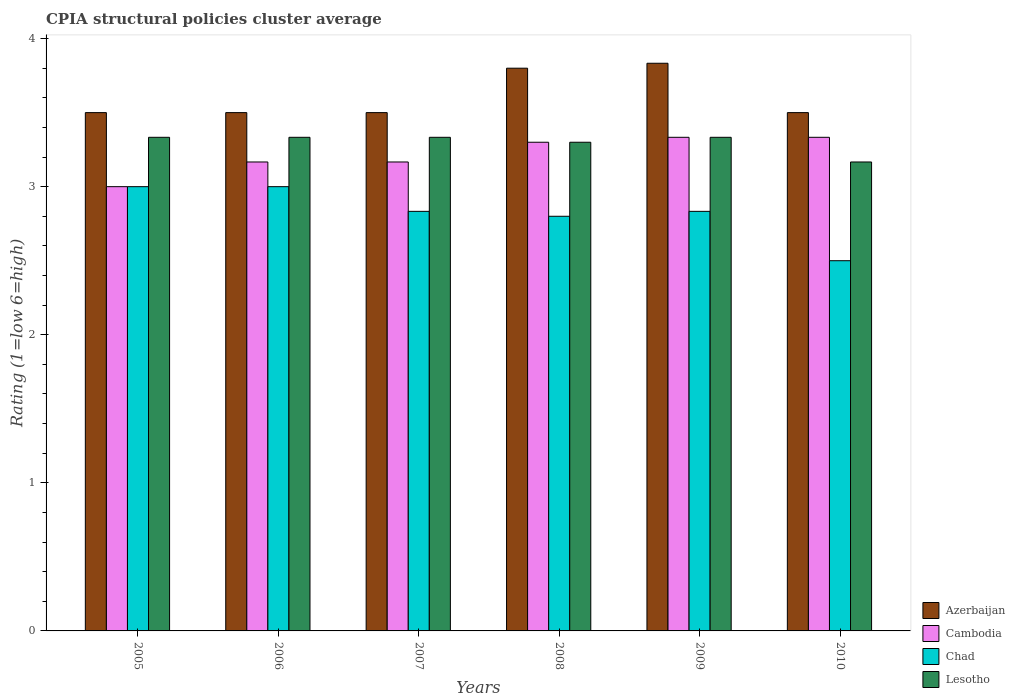Are the number of bars on each tick of the X-axis equal?
Your response must be concise. Yes. How many bars are there on the 5th tick from the right?
Your answer should be very brief. 4. What is the CPIA rating in Azerbaijan in 2010?
Give a very brief answer. 3.5. Across all years, what is the maximum CPIA rating in Lesotho?
Give a very brief answer. 3.33. Across all years, what is the minimum CPIA rating in Azerbaijan?
Your response must be concise. 3.5. In which year was the CPIA rating in Lesotho maximum?
Your response must be concise. 2005. What is the total CPIA rating in Lesotho in the graph?
Make the answer very short. 19.8. What is the difference between the CPIA rating in Chad in 2005 and that in 2010?
Keep it short and to the point. 0.5. What is the difference between the CPIA rating in Azerbaijan in 2007 and the CPIA rating in Chad in 2009?
Keep it short and to the point. 0.67. What is the average CPIA rating in Lesotho per year?
Ensure brevity in your answer.  3.3. In the year 2010, what is the difference between the CPIA rating in Chad and CPIA rating in Lesotho?
Give a very brief answer. -0.67. In how many years, is the CPIA rating in Lesotho greater than 1.2?
Offer a very short reply. 6. What is the ratio of the CPIA rating in Cambodia in 2005 to that in 2007?
Provide a short and direct response. 0.95. Is the CPIA rating in Cambodia in 2006 less than that in 2009?
Your response must be concise. Yes. Is the difference between the CPIA rating in Chad in 2008 and 2010 greater than the difference between the CPIA rating in Lesotho in 2008 and 2010?
Give a very brief answer. Yes. What is the difference between the highest and the second highest CPIA rating in Lesotho?
Ensure brevity in your answer.  0. Is the sum of the CPIA rating in Lesotho in 2006 and 2008 greater than the maximum CPIA rating in Chad across all years?
Make the answer very short. Yes. Is it the case that in every year, the sum of the CPIA rating in Lesotho and CPIA rating in Cambodia is greater than the sum of CPIA rating in Azerbaijan and CPIA rating in Chad?
Your response must be concise. No. What does the 1st bar from the left in 2009 represents?
Offer a terse response. Azerbaijan. What does the 3rd bar from the right in 2009 represents?
Give a very brief answer. Cambodia. Are all the bars in the graph horizontal?
Offer a very short reply. No. What is the difference between two consecutive major ticks on the Y-axis?
Keep it short and to the point. 1. Does the graph contain grids?
Provide a succinct answer. No. How are the legend labels stacked?
Your answer should be compact. Vertical. What is the title of the graph?
Give a very brief answer. CPIA structural policies cluster average. What is the label or title of the Y-axis?
Keep it short and to the point. Rating (1=low 6=high). What is the Rating (1=low 6=high) in Cambodia in 2005?
Make the answer very short. 3. What is the Rating (1=low 6=high) in Chad in 2005?
Provide a succinct answer. 3. What is the Rating (1=low 6=high) in Lesotho in 2005?
Your answer should be compact. 3.33. What is the Rating (1=low 6=high) of Cambodia in 2006?
Keep it short and to the point. 3.17. What is the Rating (1=low 6=high) of Lesotho in 2006?
Provide a short and direct response. 3.33. What is the Rating (1=low 6=high) of Azerbaijan in 2007?
Provide a succinct answer. 3.5. What is the Rating (1=low 6=high) of Cambodia in 2007?
Make the answer very short. 3.17. What is the Rating (1=low 6=high) in Chad in 2007?
Provide a succinct answer. 2.83. What is the Rating (1=low 6=high) of Lesotho in 2007?
Provide a short and direct response. 3.33. What is the Rating (1=low 6=high) in Chad in 2008?
Offer a terse response. 2.8. What is the Rating (1=low 6=high) of Azerbaijan in 2009?
Give a very brief answer. 3.83. What is the Rating (1=low 6=high) of Cambodia in 2009?
Keep it short and to the point. 3.33. What is the Rating (1=low 6=high) of Chad in 2009?
Your answer should be very brief. 2.83. What is the Rating (1=low 6=high) of Lesotho in 2009?
Give a very brief answer. 3.33. What is the Rating (1=low 6=high) in Cambodia in 2010?
Your answer should be compact. 3.33. What is the Rating (1=low 6=high) in Lesotho in 2010?
Your response must be concise. 3.17. Across all years, what is the maximum Rating (1=low 6=high) of Azerbaijan?
Your answer should be compact. 3.83. Across all years, what is the maximum Rating (1=low 6=high) in Cambodia?
Your answer should be compact. 3.33. Across all years, what is the maximum Rating (1=low 6=high) in Lesotho?
Ensure brevity in your answer.  3.33. Across all years, what is the minimum Rating (1=low 6=high) of Azerbaijan?
Offer a very short reply. 3.5. Across all years, what is the minimum Rating (1=low 6=high) in Lesotho?
Ensure brevity in your answer.  3.17. What is the total Rating (1=low 6=high) of Azerbaijan in the graph?
Keep it short and to the point. 21.63. What is the total Rating (1=low 6=high) of Cambodia in the graph?
Offer a very short reply. 19.3. What is the total Rating (1=low 6=high) in Chad in the graph?
Your answer should be very brief. 16.97. What is the total Rating (1=low 6=high) of Lesotho in the graph?
Keep it short and to the point. 19.8. What is the difference between the Rating (1=low 6=high) in Cambodia in 2005 and that in 2006?
Offer a terse response. -0.17. What is the difference between the Rating (1=low 6=high) of Lesotho in 2005 and that in 2006?
Provide a short and direct response. 0. What is the difference between the Rating (1=low 6=high) in Cambodia in 2005 and that in 2007?
Provide a short and direct response. -0.17. What is the difference between the Rating (1=low 6=high) of Chad in 2005 and that in 2007?
Keep it short and to the point. 0.17. What is the difference between the Rating (1=low 6=high) in Lesotho in 2005 and that in 2007?
Provide a succinct answer. 0. What is the difference between the Rating (1=low 6=high) of Cambodia in 2005 and that in 2008?
Keep it short and to the point. -0.3. What is the difference between the Rating (1=low 6=high) of Chad in 2005 and that in 2008?
Provide a short and direct response. 0.2. What is the difference between the Rating (1=low 6=high) in Lesotho in 2005 and that in 2008?
Make the answer very short. 0.03. What is the difference between the Rating (1=low 6=high) of Azerbaijan in 2005 and that in 2009?
Your answer should be compact. -0.33. What is the difference between the Rating (1=low 6=high) of Lesotho in 2005 and that in 2009?
Keep it short and to the point. 0. What is the difference between the Rating (1=low 6=high) of Cambodia in 2005 and that in 2010?
Ensure brevity in your answer.  -0.33. What is the difference between the Rating (1=low 6=high) of Lesotho in 2005 and that in 2010?
Provide a succinct answer. 0.17. What is the difference between the Rating (1=low 6=high) in Cambodia in 2006 and that in 2007?
Give a very brief answer. 0. What is the difference between the Rating (1=low 6=high) of Chad in 2006 and that in 2007?
Your answer should be very brief. 0.17. What is the difference between the Rating (1=low 6=high) in Azerbaijan in 2006 and that in 2008?
Give a very brief answer. -0.3. What is the difference between the Rating (1=low 6=high) in Cambodia in 2006 and that in 2008?
Your answer should be compact. -0.13. What is the difference between the Rating (1=low 6=high) in Chad in 2006 and that in 2008?
Give a very brief answer. 0.2. What is the difference between the Rating (1=low 6=high) in Cambodia in 2006 and that in 2009?
Offer a very short reply. -0.17. What is the difference between the Rating (1=low 6=high) in Chad in 2006 and that in 2009?
Offer a very short reply. 0.17. What is the difference between the Rating (1=low 6=high) of Azerbaijan in 2006 and that in 2010?
Give a very brief answer. 0. What is the difference between the Rating (1=low 6=high) in Chad in 2006 and that in 2010?
Provide a succinct answer. 0.5. What is the difference between the Rating (1=low 6=high) in Cambodia in 2007 and that in 2008?
Make the answer very short. -0.13. What is the difference between the Rating (1=low 6=high) of Chad in 2007 and that in 2008?
Your response must be concise. 0.03. What is the difference between the Rating (1=low 6=high) in Azerbaijan in 2007 and that in 2009?
Your response must be concise. -0.33. What is the difference between the Rating (1=low 6=high) of Cambodia in 2007 and that in 2009?
Keep it short and to the point. -0.17. What is the difference between the Rating (1=low 6=high) of Chad in 2007 and that in 2009?
Make the answer very short. 0. What is the difference between the Rating (1=low 6=high) of Azerbaijan in 2007 and that in 2010?
Make the answer very short. 0. What is the difference between the Rating (1=low 6=high) in Lesotho in 2007 and that in 2010?
Ensure brevity in your answer.  0.17. What is the difference between the Rating (1=low 6=high) in Azerbaijan in 2008 and that in 2009?
Your response must be concise. -0.03. What is the difference between the Rating (1=low 6=high) in Cambodia in 2008 and that in 2009?
Provide a short and direct response. -0.03. What is the difference between the Rating (1=low 6=high) in Chad in 2008 and that in 2009?
Make the answer very short. -0.03. What is the difference between the Rating (1=low 6=high) in Lesotho in 2008 and that in 2009?
Provide a short and direct response. -0.03. What is the difference between the Rating (1=low 6=high) of Azerbaijan in 2008 and that in 2010?
Keep it short and to the point. 0.3. What is the difference between the Rating (1=low 6=high) in Cambodia in 2008 and that in 2010?
Provide a succinct answer. -0.03. What is the difference between the Rating (1=low 6=high) in Chad in 2008 and that in 2010?
Keep it short and to the point. 0.3. What is the difference between the Rating (1=low 6=high) in Lesotho in 2008 and that in 2010?
Ensure brevity in your answer.  0.13. What is the difference between the Rating (1=low 6=high) in Azerbaijan in 2009 and that in 2010?
Offer a very short reply. 0.33. What is the difference between the Rating (1=low 6=high) of Chad in 2009 and that in 2010?
Provide a succinct answer. 0.33. What is the difference between the Rating (1=low 6=high) in Lesotho in 2009 and that in 2010?
Offer a very short reply. 0.17. What is the difference between the Rating (1=low 6=high) in Azerbaijan in 2005 and the Rating (1=low 6=high) in Chad in 2006?
Your answer should be very brief. 0.5. What is the difference between the Rating (1=low 6=high) of Azerbaijan in 2005 and the Rating (1=low 6=high) of Lesotho in 2006?
Give a very brief answer. 0.17. What is the difference between the Rating (1=low 6=high) in Cambodia in 2005 and the Rating (1=low 6=high) in Lesotho in 2006?
Make the answer very short. -0.33. What is the difference between the Rating (1=low 6=high) of Azerbaijan in 2005 and the Rating (1=low 6=high) of Cambodia in 2007?
Ensure brevity in your answer.  0.33. What is the difference between the Rating (1=low 6=high) of Azerbaijan in 2005 and the Rating (1=low 6=high) of Chad in 2007?
Provide a succinct answer. 0.67. What is the difference between the Rating (1=low 6=high) in Cambodia in 2005 and the Rating (1=low 6=high) in Chad in 2007?
Your response must be concise. 0.17. What is the difference between the Rating (1=low 6=high) of Azerbaijan in 2005 and the Rating (1=low 6=high) of Chad in 2008?
Ensure brevity in your answer.  0.7. What is the difference between the Rating (1=low 6=high) of Cambodia in 2005 and the Rating (1=low 6=high) of Chad in 2008?
Your answer should be compact. 0.2. What is the difference between the Rating (1=low 6=high) in Azerbaijan in 2005 and the Rating (1=low 6=high) in Lesotho in 2009?
Ensure brevity in your answer.  0.17. What is the difference between the Rating (1=low 6=high) in Cambodia in 2005 and the Rating (1=low 6=high) in Lesotho in 2009?
Your answer should be compact. -0.33. What is the difference between the Rating (1=low 6=high) of Azerbaijan in 2005 and the Rating (1=low 6=high) of Chad in 2010?
Make the answer very short. 1. What is the difference between the Rating (1=low 6=high) in Cambodia in 2005 and the Rating (1=low 6=high) in Chad in 2010?
Your response must be concise. 0.5. What is the difference between the Rating (1=low 6=high) in Azerbaijan in 2006 and the Rating (1=low 6=high) in Chad in 2007?
Your answer should be very brief. 0.67. What is the difference between the Rating (1=low 6=high) of Cambodia in 2006 and the Rating (1=low 6=high) of Chad in 2007?
Offer a very short reply. 0.33. What is the difference between the Rating (1=low 6=high) in Cambodia in 2006 and the Rating (1=low 6=high) in Lesotho in 2007?
Your answer should be very brief. -0.17. What is the difference between the Rating (1=low 6=high) of Azerbaijan in 2006 and the Rating (1=low 6=high) of Cambodia in 2008?
Provide a short and direct response. 0.2. What is the difference between the Rating (1=low 6=high) in Azerbaijan in 2006 and the Rating (1=low 6=high) in Chad in 2008?
Offer a terse response. 0.7. What is the difference between the Rating (1=low 6=high) of Cambodia in 2006 and the Rating (1=low 6=high) of Chad in 2008?
Offer a terse response. 0.37. What is the difference between the Rating (1=low 6=high) in Cambodia in 2006 and the Rating (1=low 6=high) in Lesotho in 2008?
Your answer should be very brief. -0.13. What is the difference between the Rating (1=low 6=high) in Chad in 2006 and the Rating (1=low 6=high) in Lesotho in 2008?
Your response must be concise. -0.3. What is the difference between the Rating (1=low 6=high) in Azerbaijan in 2006 and the Rating (1=low 6=high) in Cambodia in 2009?
Ensure brevity in your answer.  0.17. What is the difference between the Rating (1=low 6=high) in Cambodia in 2006 and the Rating (1=low 6=high) in Lesotho in 2009?
Offer a terse response. -0.17. What is the difference between the Rating (1=low 6=high) of Azerbaijan in 2006 and the Rating (1=low 6=high) of Cambodia in 2010?
Ensure brevity in your answer.  0.17. What is the difference between the Rating (1=low 6=high) of Azerbaijan in 2006 and the Rating (1=low 6=high) of Chad in 2010?
Keep it short and to the point. 1. What is the difference between the Rating (1=low 6=high) in Azerbaijan in 2006 and the Rating (1=low 6=high) in Lesotho in 2010?
Give a very brief answer. 0.33. What is the difference between the Rating (1=low 6=high) of Azerbaijan in 2007 and the Rating (1=low 6=high) of Lesotho in 2008?
Keep it short and to the point. 0.2. What is the difference between the Rating (1=low 6=high) in Cambodia in 2007 and the Rating (1=low 6=high) in Chad in 2008?
Make the answer very short. 0.37. What is the difference between the Rating (1=low 6=high) in Cambodia in 2007 and the Rating (1=low 6=high) in Lesotho in 2008?
Provide a succinct answer. -0.13. What is the difference between the Rating (1=low 6=high) in Chad in 2007 and the Rating (1=low 6=high) in Lesotho in 2008?
Offer a terse response. -0.47. What is the difference between the Rating (1=low 6=high) of Azerbaijan in 2007 and the Rating (1=low 6=high) of Cambodia in 2009?
Keep it short and to the point. 0.17. What is the difference between the Rating (1=low 6=high) in Azerbaijan in 2007 and the Rating (1=low 6=high) in Chad in 2009?
Offer a terse response. 0.67. What is the difference between the Rating (1=low 6=high) of Cambodia in 2007 and the Rating (1=low 6=high) of Chad in 2009?
Give a very brief answer. 0.33. What is the difference between the Rating (1=low 6=high) of Cambodia in 2007 and the Rating (1=low 6=high) of Lesotho in 2010?
Your response must be concise. 0. What is the difference between the Rating (1=low 6=high) in Chad in 2007 and the Rating (1=low 6=high) in Lesotho in 2010?
Keep it short and to the point. -0.33. What is the difference between the Rating (1=low 6=high) in Azerbaijan in 2008 and the Rating (1=low 6=high) in Cambodia in 2009?
Provide a short and direct response. 0.47. What is the difference between the Rating (1=low 6=high) of Azerbaijan in 2008 and the Rating (1=low 6=high) of Chad in 2009?
Offer a very short reply. 0.97. What is the difference between the Rating (1=low 6=high) of Azerbaijan in 2008 and the Rating (1=low 6=high) of Lesotho in 2009?
Provide a succinct answer. 0.47. What is the difference between the Rating (1=low 6=high) of Cambodia in 2008 and the Rating (1=low 6=high) of Chad in 2009?
Offer a very short reply. 0.47. What is the difference between the Rating (1=low 6=high) in Cambodia in 2008 and the Rating (1=low 6=high) in Lesotho in 2009?
Make the answer very short. -0.03. What is the difference between the Rating (1=low 6=high) in Chad in 2008 and the Rating (1=low 6=high) in Lesotho in 2009?
Your response must be concise. -0.53. What is the difference between the Rating (1=low 6=high) in Azerbaijan in 2008 and the Rating (1=low 6=high) in Cambodia in 2010?
Your response must be concise. 0.47. What is the difference between the Rating (1=low 6=high) of Azerbaijan in 2008 and the Rating (1=low 6=high) of Chad in 2010?
Make the answer very short. 1.3. What is the difference between the Rating (1=low 6=high) in Azerbaijan in 2008 and the Rating (1=low 6=high) in Lesotho in 2010?
Your answer should be compact. 0.63. What is the difference between the Rating (1=low 6=high) of Cambodia in 2008 and the Rating (1=low 6=high) of Chad in 2010?
Your response must be concise. 0.8. What is the difference between the Rating (1=low 6=high) in Cambodia in 2008 and the Rating (1=low 6=high) in Lesotho in 2010?
Your answer should be compact. 0.13. What is the difference between the Rating (1=low 6=high) of Chad in 2008 and the Rating (1=low 6=high) of Lesotho in 2010?
Offer a very short reply. -0.37. What is the difference between the Rating (1=low 6=high) of Azerbaijan in 2009 and the Rating (1=low 6=high) of Lesotho in 2010?
Provide a succinct answer. 0.67. What is the difference between the Rating (1=low 6=high) of Chad in 2009 and the Rating (1=low 6=high) of Lesotho in 2010?
Provide a succinct answer. -0.33. What is the average Rating (1=low 6=high) of Azerbaijan per year?
Offer a terse response. 3.61. What is the average Rating (1=low 6=high) of Cambodia per year?
Your response must be concise. 3.22. What is the average Rating (1=low 6=high) of Chad per year?
Make the answer very short. 2.83. In the year 2005, what is the difference between the Rating (1=low 6=high) in Azerbaijan and Rating (1=low 6=high) in Cambodia?
Make the answer very short. 0.5. In the year 2005, what is the difference between the Rating (1=low 6=high) of Cambodia and Rating (1=low 6=high) of Chad?
Provide a short and direct response. 0. In the year 2006, what is the difference between the Rating (1=low 6=high) in Azerbaijan and Rating (1=low 6=high) in Cambodia?
Make the answer very short. 0.33. In the year 2006, what is the difference between the Rating (1=low 6=high) in Azerbaijan and Rating (1=low 6=high) in Chad?
Offer a very short reply. 0.5. In the year 2006, what is the difference between the Rating (1=low 6=high) of Azerbaijan and Rating (1=low 6=high) of Lesotho?
Your answer should be compact. 0.17. In the year 2006, what is the difference between the Rating (1=low 6=high) of Cambodia and Rating (1=low 6=high) of Lesotho?
Provide a succinct answer. -0.17. In the year 2007, what is the difference between the Rating (1=low 6=high) in Azerbaijan and Rating (1=low 6=high) in Cambodia?
Your answer should be compact. 0.33. In the year 2007, what is the difference between the Rating (1=low 6=high) in Azerbaijan and Rating (1=low 6=high) in Chad?
Offer a terse response. 0.67. In the year 2007, what is the difference between the Rating (1=low 6=high) in Azerbaijan and Rating (1=low 6=high) in Lesotho?
Keep it short and to the point. 0.17. In the year 2007, what is the difference between the Rating (1=low 6=high) of Cambodia and Rating (1=low 6=high) of Chad?
Offer a very short reply. 0.33. In the year 2007, what is the difference between the Rating (1=low 6=high) in Cambodia and Rating (1=low 6=high) in Lesotho?
Provide a succinct answer. -0.17. In the year 2007, what is the difference between the Rating (1=low 6=high) in Chad and Rating (1=low 6=high) in Lesotho?
Offer a terse response. -0.5. In the year 2008, what is the difference between the Rating (1=low 6=high) in Cambodia and Rating (1=low 6=high) in Chad?
Your answer should be compact. 0.5. In the year 2008, what is the difference between the Rating (1=low 6=high) of Chad and Rating (1=low 6=high) of Lesotho?
Your answer should be compact. -0.5. In the year 2009, what is the difference between the Rating (1=low 6=high) of Cambodia and Rating (1=low 6=high) of Chad?
Ensure brevity in your answer.  0.5. In the year 2009, what is the difference between the Rating (1=low 6=high) in Cambodia and Rating (1=low 6=high) in Lesotho?
Keep it short and to the point. 0. In the year 2010, what is the difference between the Rating (1=low 6=high) of Azerbaijan and Rating (1=low 6=high) of Cambodia?
Keep it short and to the point. 0.17. In the year 2010, what is the difference between the Rating (1=low 6=high) of Azerbaijan and Rating (1=low 6=high) of Lesotho?
Offer a very short reply. 0.33. In the year 2010, what is the difference between the Rating (1=low 6=high) in Chad and Rating (1=low 6=high) in Lesotho?
Your answer should be compact. -0.67. What is the ratio of the Rating (1=low 6=high) in Chad in 2005 to that in 2006?
Ensure brevity in your answer.  1. What is the ratio of the Rating (1=low 6=high) of Cambodia in 2005 to that in 2007?
Your response must be concise. 0.95. What is the ratio of the Rating (1=low 6=high) in Chad in 2005 to that in 2007?
Your answer should be compact. 1.06. What is the ratio of the Rating (1=low 6=high) of Lesotho in 2005 to that in 2007?
Offer a very short reply. 1. What is the ratio of the Rating (1=low 6=high) in Azerbaijan in 2005 to that in 2008?
Provide a short and direct response. 0.92. What is the ratio of the Rating (1=low 6=high) of Chad in 2005 to that in 2008?
Ensure brevity in your answer.  1.07. What is the ratio of the Rating (1=low 6=high) in Lesotho in 2005 to that in 2008?
Offer a very short reply. 1.01. What is the ratio of the Rating (1=low 6=high) of Azerbaijan in 2005 to that in 2009?
Your answer should be compact. 0.91. What is the ratio of the Rating (1=low 6=high) in Chad in 2005 to that in 2009?
Provide a succinct answer. 1.06. What is the ratio of the Rating (1=low 6=high) of Azerbaijan in 2005 to that in 2010?
Offer a terse response. 1. What is the ratio of the Rating (1=low 6=high) in Lesotho in 2005 to that in 2010?
Your response must be concise. 1.05. What is the ratio of the Rating (1=low 6=high) of Azerbaijan in 2006 to that in 2007?
Ensure brevity in your answer.  1. What is the ratio of the Rating (1=low 6=high) in Chad in 2006 to that in 2007?
Keep it short and to the point. 1.06. What is the ratio of the Rating (1=low 6=high) in Azerbaijan in 2006 to that in 2008?
Your answer should be very brief. 0.92. What is the ratio of the Rating (1=low 6=high) of Cambodia in 2006 to that in 2008?
Your answer should be very brief. 0.96. What is the ratio of the Rating (1=low 6=high) of Chad in 2006 to that in 2008?
Keep it short and to the point. 1.07. What is the ratio of the Rating (1=low 6=high) in Azerbaijan in 2006 to that in 2009?
Your response must be concise. 0.91. What is the ratio of the Rating (1=low 6=high) in Cambodia in 2006 to that in 2009?
Give a very brief answer. 0.95. What is the ratio of the Rating (1=low 6=high) of Chad in 2006 to that in 2009?
Your response must be concise. 1.06. What is the ratio of the Rating (1=low 6=high) in Lesotho in 2006 to that in 2009?
Make the answer very short. 1. What is the ratio of the Rating (1=low 6=high) in Azerbaijan in 2006 to that in 2010?
Ensure brevity in your answer.  1. What is the ratio of the Rating (1=low 6=high) in Lesotho in 2006 to that in 2010?
Make the answer very short. 1.05. What is the ratio of the Rating (1=low 6=high) in Azerbaijan in 2007 to that in 2008?
Offer a very short reply. 0.92. What is the ratio of the Rating (1=low 6=high) in Cambodia in 2007 to that in 2008?
Your response must be concise. 0.96. What is the ratio of the Rating (1=low 6=high) in Chad in 2007 to that in 2008?
Offer a terse response. 1.01. What is the ratio of the Rating (1=low 6=high) in Lesotho in 2007 to that in 2008?
Provide a short and direct response. 1.01. What is the ratio of the Rating (1=low 6=high) in Cambodia in 2007 to that in 2009?
Give a very brief answer. 0.95. What is the ratio of the Rating (1=low 6=high) in Lesotho in 2007 to that in 2009?
Provide a succinct answer. 1. What is the ratio of the Rating (1=low 6=high) in Azerbaijan in 2007 to that in 2010?
Give a very brief answer. 1. What is the ratio of the Rating (1=low 6=high) in Cambodia in 2007 to that in 2010?
Your answer should be compact. 0.95. What is the ratio of the Rating (1=low 6=high) of Chad in 2007 to that in 2010?
Offer a terse response. 1.13. What is the ratio of the Rating (1=low 6=high) in Lesotho in 2007 to that in 2010?
Offer a very short reply. 1.05. What is the ratio of the Rating (1=low 6=high) of Azerbaijan in 2008 to that in 2009?
Offer a terse response. 0.99. What is the ratio of the Rating (1=low 6=high) in Cambodia in 2008 to that in 2009?
Provide a short and direct response. 0.99. What is the ratio of the Rating (1=low 6=high) of Chad in 2008 to that in 2009?
Your answer should be very brief. 0.99. What is the ratio of the Rating (1=low 6=high) in Azerbaijan in 2008 to that in 2010?
Make the answer very short. 1.09. What is the ratio of the Rating (1=low 6=high) of Chad in 2008 to that in 2010?
Ensure brevity in your answer.  1.12. What is the ratio of the Rating (1=low 6=high) of Lesotho in 2008 to that in 2010?
Give a very brief answer. 1.04. What is the ratio of the Rating (1=low 6=high) of Azerbaijan in 2009 to that in 2010?
Offer a very short reply. 1.1. What is the ratio of the Rating (1=low 6=high) in Cambodia in 2009 to that in 2010?
Your answer should be compact. 1. What is the ratio of the Rating (1=low 6=high) in Chad in 2009 to that in 2010?
Your answer should be compact. 1.13. What is the ratio of the Rating (1=low 6=high) of Lesotho in 2009 to that in 2010?
Ensure brevity in your answer.  1.05. What is the difference between the highest and the second highest Rating (1=low 6=high) of Chad?
Ensure brevity in your answer.  0. What is the difference between the highest and the lowest Rating (1=low 6=high) of Cambodia?
Make the answer very short. 0.33. 